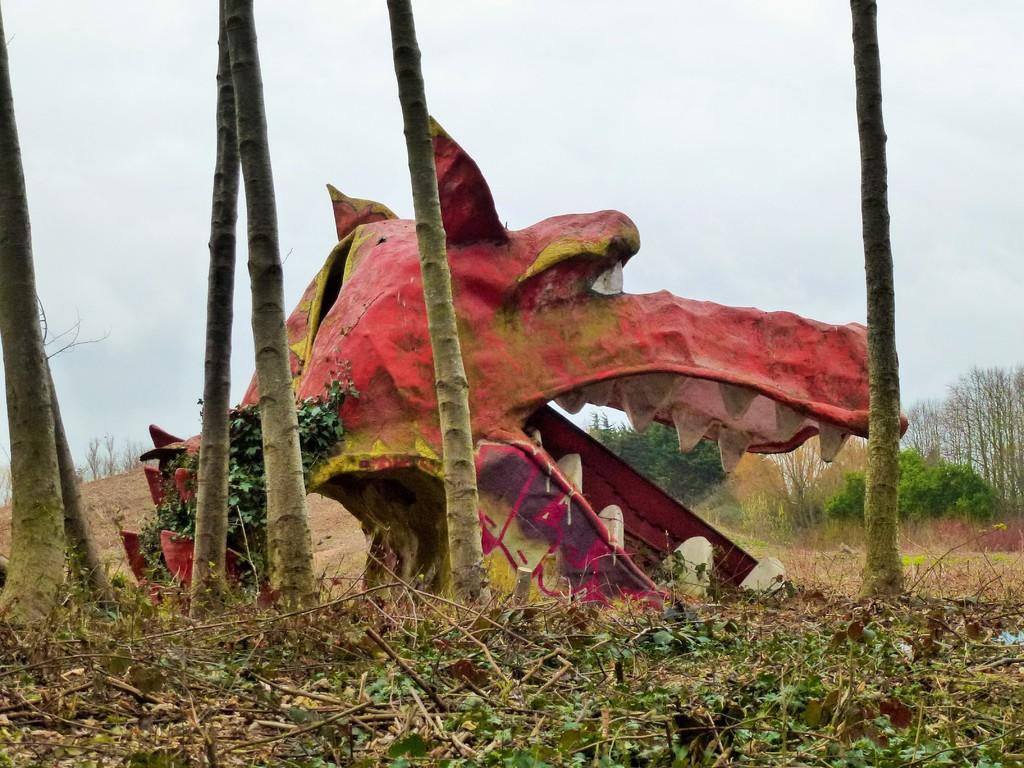What is the main subject of the image? There is a sculpture in the image. What other elements can be seen in the image besides the sculpture? There are plants and wooden poles visible in the image. What can be seen in the background of the image? There is a group of trees and the sky visible in the background of the image. What country is the parent of the aunt mentioned in the image? There is no mention of a country, parent, or aunt in the image, as the facts provided do not include any information about these topics. 